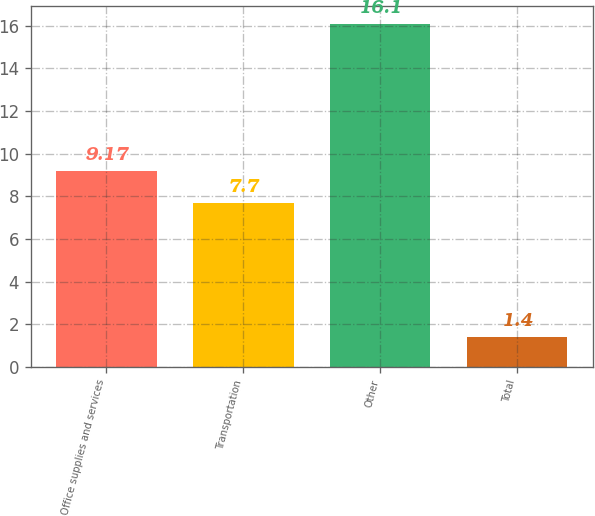<chart> <loc_0><loc_0><loc_500><loc_500><bar_chart><fcel>Office supplies and services<fcel>Transportation<fcel>Other<fcel>Total<nl><fcel>9.17<fcel>7.7<fcel>16.1<fcel>1.4<nl></chart> 